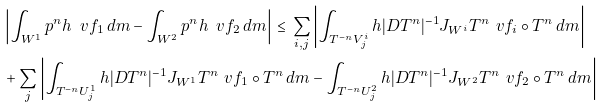Convert formula to latex. <formula><loc_0><loc_0><loc_500><loc_500>& \left | \int _ { W ^ { 1 } } \L p ^ { n } h \, \ v f _ { 1 } \, d m - \int _ { W ^ { 2 } } \L p ^ { n } h \, \ v f _ { 2 } \, d m \right | \, \leq \, \sum _ { i , j } \left | \int _ { T ^ { - n } V ^ { i } _ { j } } h | D T ^ { n } | ^ { - 1 } J _ { W ^ { i } } T ^ { n } \ v f _ { i } \circ T ^ { n } \, d m \right | \\ & + \sum _ { j } \left | \int _ { T ^ { - n } U ^ { 1 } _ { j } } h | D T ^ { n } | ^ { - 1 } J _ { W ^ { 1 } } T ^ { n } \ v f _ { 1 } \circ T ^ { n } \, d m - \int _ { T ^ { - n } U ^ { 2 } _ { j } } h | D T ^ { n } | ^ { - 1 } J _ { W ^ { 2 } } T ^ { n } \ v f _ { 2 } \circ T ^ { n } \, d m \right |</formula> 